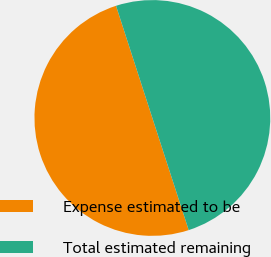<chart> <loc_0><loc_0><loc_500><loc_500><pie_chart><fcel>Expense estimated to be<fcel>Total estimated remaining<nl><fcel>50.0%<fcel>50.0%<nl></chart> 